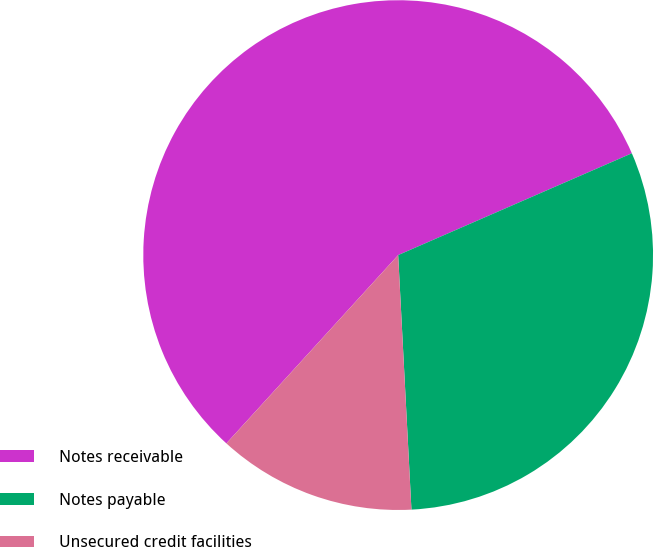Convert chart to OTSL. <chart><loc_0><loc_0><loc_500><loc_500><pie_chart><fcel>Notes receivable<fcel>Notes payable<fcel>Unsecured credit facilities<nl><fcel>56.69%<fcel>30.71%<fcel>12.6%<nl></chart> 